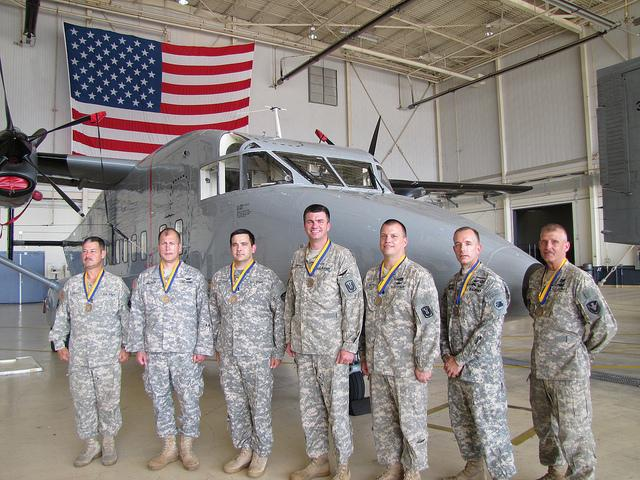How do the people know each other?

Choices:
A) rivals
B) coworkers
C) siblings
D) neighbors coworkers 